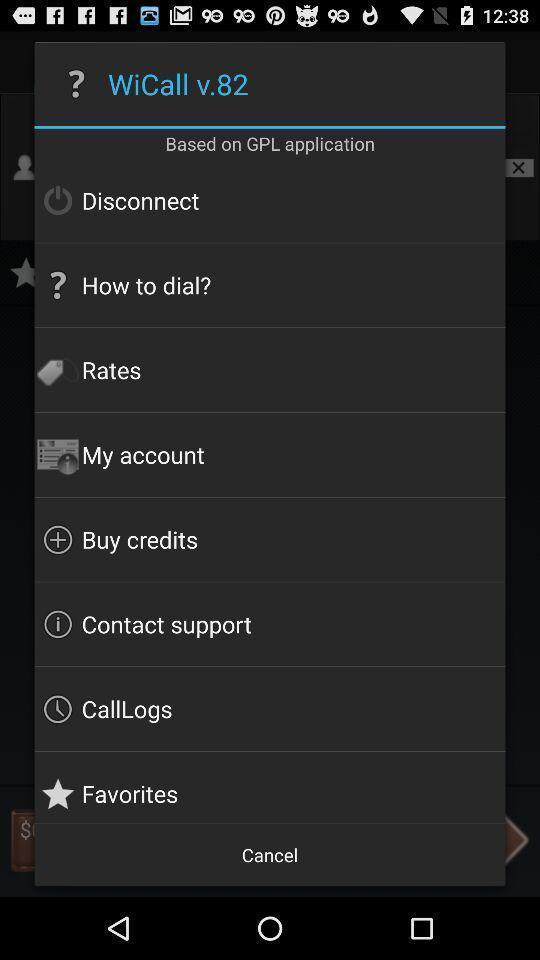Provide a detailed account of this screenshot. Pop-up showing multiple options. 